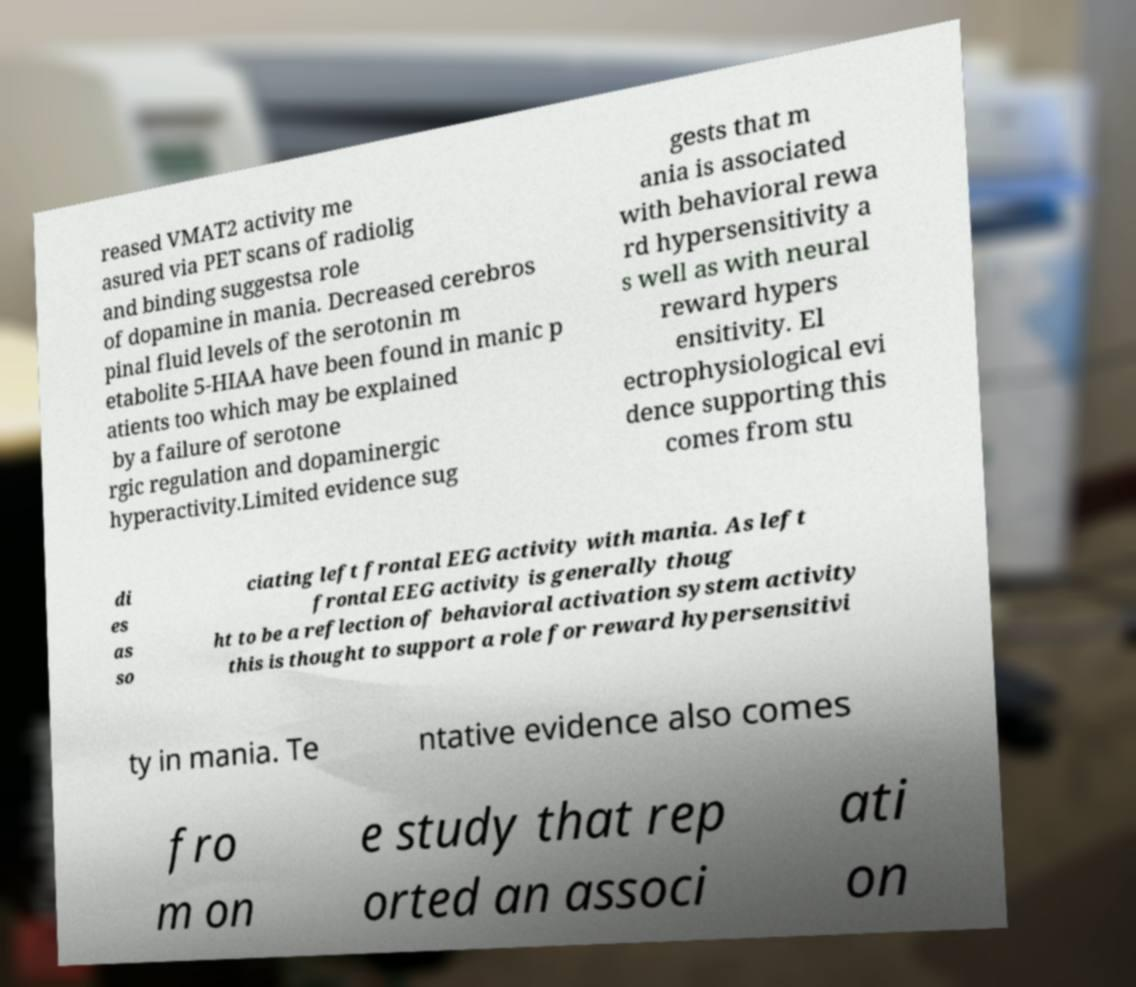What messages or text are displayed in this image? I need them in a readable, typed format. reased VMAT2 activity me asured via PET scans of radiolig and binding suggestsa role of dopamine in mania. Decreased cerebros pinal fluid levels of the serotonin m etabolite 5-HIAA have been found in manic p atients too which may be explained by a failure of serotone rgic regulation and dopaminergic hyperactivity.Limited evidence sug gests that m ania is associated with behavioral rewa rd hypersensitivity a s well as with neural reward hypers ensitivity. El ectrophysiological evi dence supporting this comes from stu di es as so ciating left frontal EEG activity with mania. As left frontal EEG activity is generally thoug ht to be a reflection of behavioral activation system activity this is thought to support a role for reward hypersensitivi ty in mania. Te ntative evidence also comes fro m on e study that rep orted an associ ati on 